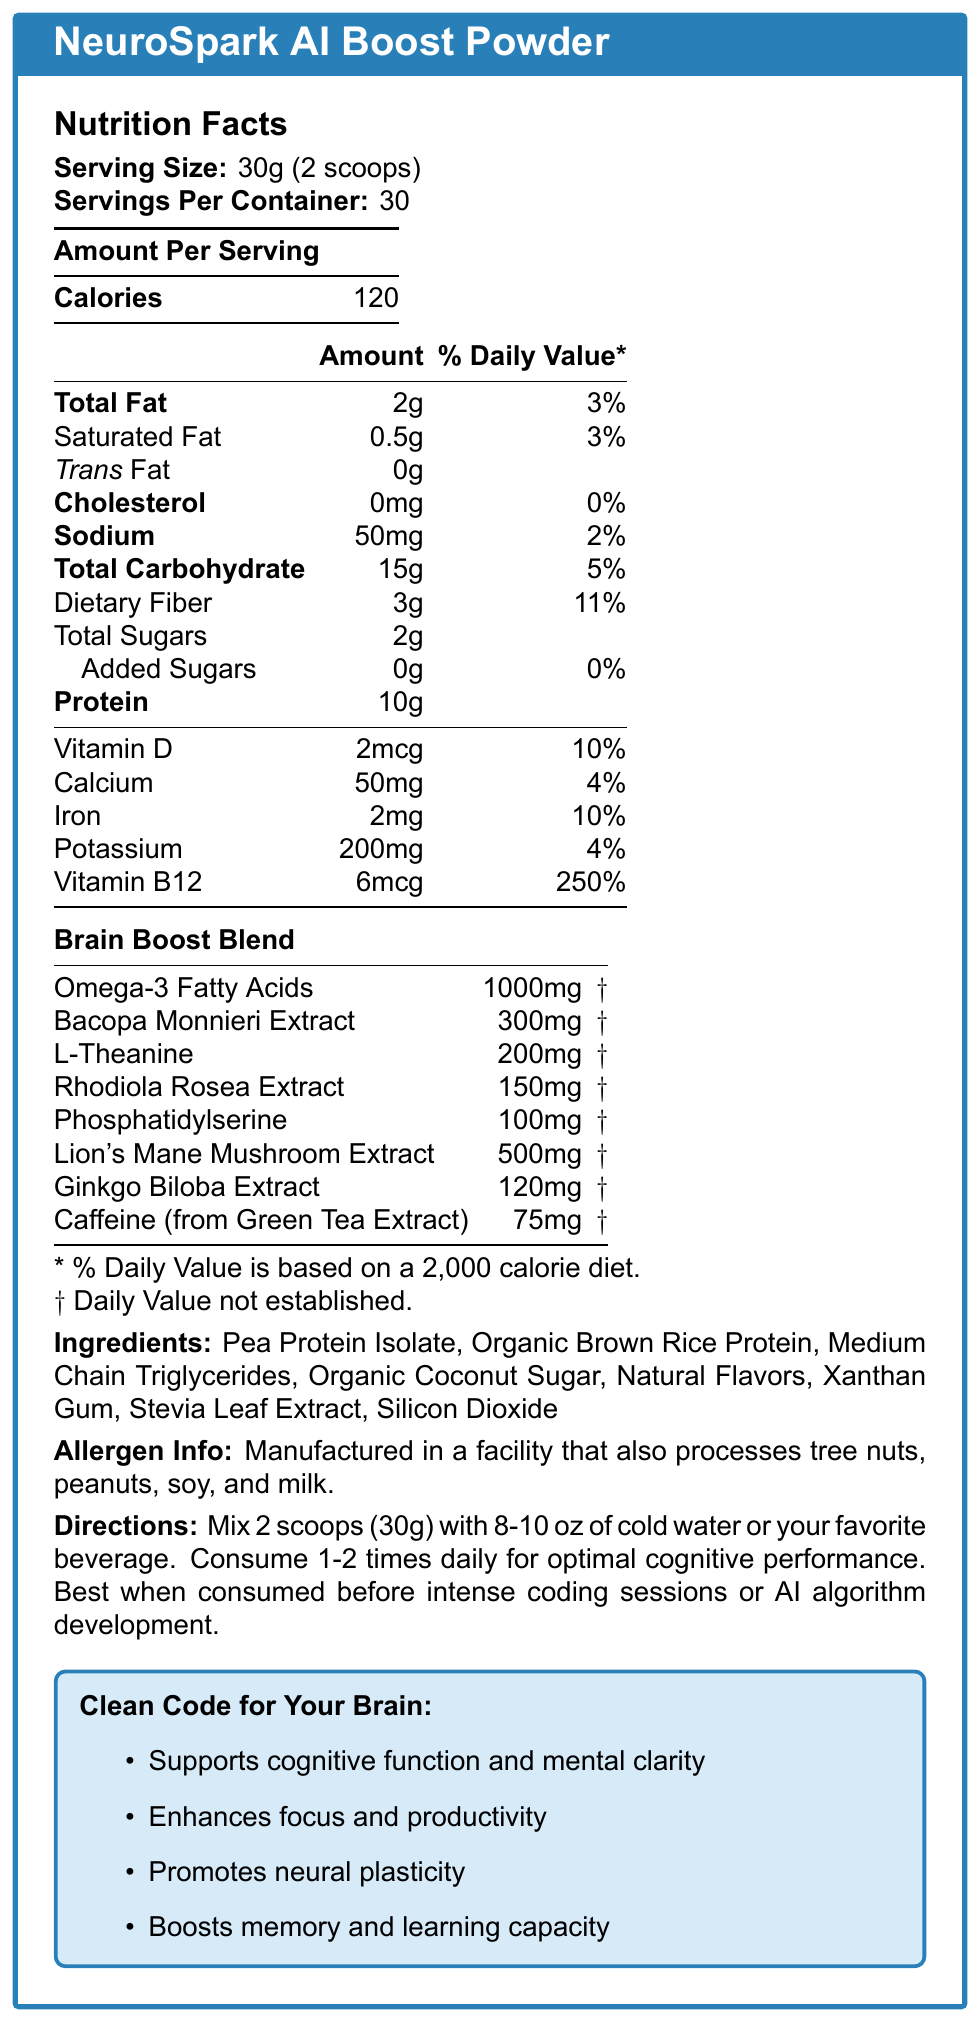what is the serving size of NeuroSpark AI Boost Powder? The document states the serving size as "30g (2 scoops)."
Answer: 30g (2 scoops) how many calories are in one serving? The document lists "Calories" as 120 per serving.
Answer: 120 what percentage of the daily value of fiber does one serving provide? The document indicates that dietary fiber per serving is 3g, providing 11% of the daily value.
Answer: 11% what is the amount of caffeine from green tea extract per serving? The document shows that caffeine from green tea extract is 75mg per serving.
Answer: 75mg are there any added sugars in this product? The document mentions "Added Sugars" as 0g, indicating no added sugars.
Answer: No which of the following ingredients is not listed in NeuroSpark AI Boost Powder? A. Pea Protein Isolate B. Organic Coconut Sugar C. Ginseng Extract D. Silicon Dioxide Ginseng Extract is not listed among the ingredients in the document.
Answer: C what is the amount of vitamin B12 in one serving of NeuroSpark AI Boost Powder? A. 2mcg B. 4mcg C. 6mcg D. 8mcg The document states the amount of vitamin B12 as "6mcg."
Answer: C is NeuroSpark AI Boost Powder suitable for someone with a peanut allergy? The document mentions: "Manufactured in a facility that also processes tree nuts, peanuts, soy, and milk," so there could be cross-contamination.
Answer: Maybe does this product contain any trans fat? The document shows "Trans Fat" as 0g.
Answer: No summarize the main idea of the NeuroSpark AI Boost Powder Nutrition Facts Label. The document provides detailed nutritional information, ingredient list, benefits claims, and directions for use, highlighting the product's focus on supporting cognitive performance for AI researchers.
Answer: NeuroSpark AI Boost Powder is a brain-boosting supplement designed to enhance cognitive functions like mental clarity, focus, and memory. It contains various ingredients like proteins, vitamins, minerals, and a specialized blend of brain-boosting compounds. Each serving provides 120 calories, with minimal fat and sugars. The label also includes allergen information and usage directions. how much sodium is in one serving? The document specifies the sodium content per serving as "50mg."
Answer: 50mg what are the main ingredients in the Brain Boost Blend? The document lists these ingredients specifically under the "Brain Boost Blend" section.
Answer: Omega-3 Fatty Acids, Bacopa Monnieri Extract, L-Theanine, Rhodiola Rosea Extract, Phosphatidylserine, Lion's Mane Mushroom Extract, Ginkgo Biloba Extract, Caffeine (from Green Tea Extract) what is the total fat content per serving, and what percentage of the daily value does it represent? The document shows "Total Fat" as 2g, representing 3% of the daily value.
Answer: 2g, 3% which claims does the NeuroSpark AI Boost Powder make? A. Supports cognitive function B. Improves physical strength C. Enhances focus and productivity D. Promotes neural plasticity E. Boosts memory and learning capacity The claims listed in the document include "Supports cognitive function and mental clarity," "Enhances focus and productivity," "Promotes neural plasticity," and "Boosts memory and learning capacity."
Answer: A, C, D, E what is the daily value percentage for iron in this product? The document indicates that iron's daily value percentage per serving is 10%.
Answer: 10% do we know where the NeuroSpark AI Boost Powder is manufactured? The document does not provide specific information about the manufacturing location.
Answer: Not enough information 